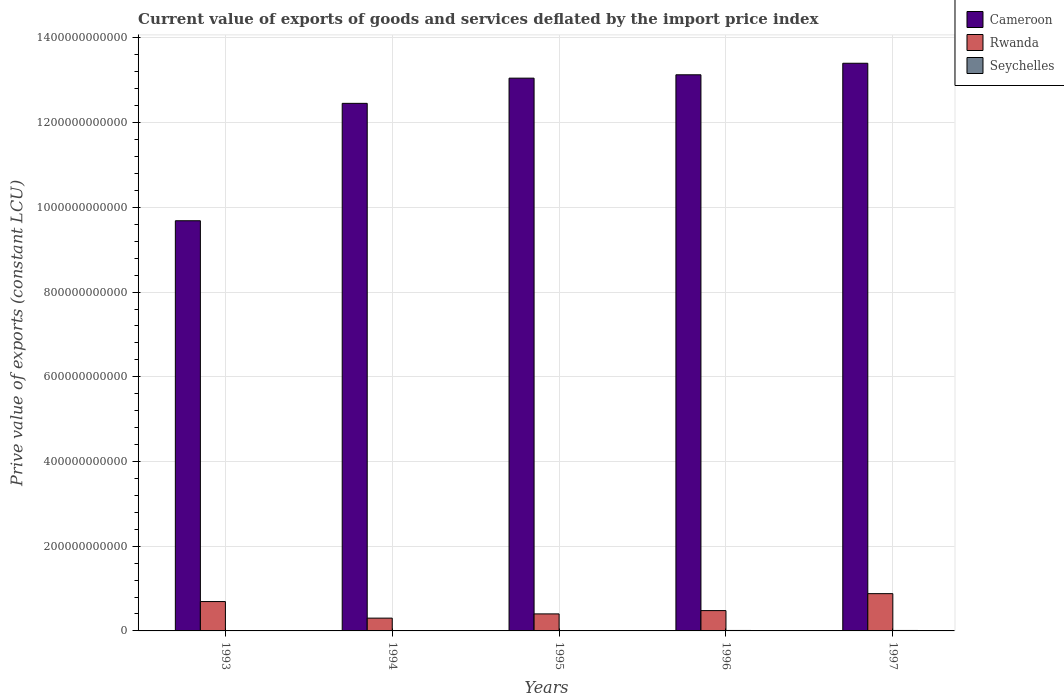How many groups of bars are there?
Offer a terse response. 5. How many bars are there on the 4th tick from the left?
Your answer should be very brief. 3. What is the label of the 5th group of bars from the left?
Ensure brevity in your answer.  1997. In how many cases, is the number of bars for a given year not equal to the number of legend labels?
Provide a short and direct response. 0. What is the prive value of exports in Cameroon in 1993?
Offer a terse response. 9.68e+11. Across all years, what is the maximum prive value of exports in Seychelles?
Give a very brief answer. 1.09e+09. Across all years, what is the minimum prive value of exports in Cameroon?
Your answer should be very brief. 9.68e+11. In which year was the prive value of exports in Rwanda maximum?
Keep it short and to the point. 1997. What is the total prive value of exports in Rwanda in the graph?
Ensure brevity in your answer.  2.76e+11. What is the difference between the prive value of exports in Cameroon in 1996 and that in 1997?
Your response must be concise. -2.72e+1. What is the difference between the prive value of exports in Seychelles in 1994 and the prive value of exports in Cameroon in 1995?
Your response must be concise. -1.30e+12. What is the average prive value of exports in Seychelles per year?
Your response must be concise. 7.48e+08. In the year 1997, what is the difference between the prive value of exports in Cameroon and prive value of exports in Seychelles?
Offer a terse response. 1.34e+12. In how many years, is the prive value of exports in Rwanda greater than 440000000000 LCU?
Keep it short and to the point. 0. What is the ratio of the prive value of exports in Seychelles in 1993 to that in 1996?
Keep it short and to the point. 0.49. Is the prive value of exports in Cameroon in 1994 less than that in 1995?
Your answer should be very brief. Yes. Is the difference between the prive value of exports in Cameroon in 1993 and 1995 greater than the difference between the prive value of exports in Seychelles in 1993 and 1995?
Your answer should be compact. No. What is the difference between the highest and the second highest prive value of exports in Seychelles?
Provide a succinct answer. 1.69e+07. What is the difference between the highest and the lowest prive value of exports in Seychelles?
Offer a very short reply. 5.79e+08. In how many years, is the prive value of exports in Seychelles greater than the average prive value of exports in Seychelles taken over all years?
Make the answer very short. 2. Is the sum of the prive value of exports in Rwanda in 1995 and 1996 greater than the maximum prive value of exports in Cameroon across all years?
Provide a succinct answer. No. What does the 3rd bar from the left in 1997 represents?
Your response must be concise. Seychelles. What does the 1st bar from the right in 1993 represents?
Provide a succinct answer. Seychelles. Is it the case that in every year, the sum of the prive value of exports in Rwanda and prive value of exports in Cameroon is greater than the prive value of exports in Seychelles?
Offer a very short reply. Yes. How many bars are there?
Ensure brevity in your answer.  15. What is the difference between two consecutive major ticks on the Y-axis?
Keep it short and to the point. 2.00e+11. Does the graph contain any zero values?
Offer a terse response. No. Does the graph contain grids?
Give a very brief answer. Yes. Where does the legend appear in the graph?
Your response must be concise. Top right. How many legend labels are there?
Provide a short and direct response. 3. How are the legend labels stacked?
Your answer should be compact. Vertical. What is the title of the graph?
Ensure brevity in your answer.  Current value of exports of goods and services deflated by the import price index. Does "Uganda" appear as one of the legend labels in the graph?
Provide a succinct answer. No. What is the label or title of the X-axis?
Your response must be concise. Years. What is the label or title of the Y-axis?
Offer a very short reply. Prive value of exports (constant LCU). What is the Prive value of exports (constant LCU) in Cameroon in 1993?
Keep it short and to the point. 9.68e+11. What is the Prive value of exports (constant LCU) in Rwanda in 1993?
Provide a short and direct response. 6.93e+1. What is the Prive value of exports (constant LCU) of Seychelles in 1993?
Your response must be concise. 5.20e+08. What is the Prive value of exports (constant LCU) of Cameroon in 1994?
Make the answer very short. 1.25e+12. What is the Prive value of exports (constant LCU) in Rwanda in 1994?
Your answer should be compact. 3.02e+1. What is the Prive value of exports (constant LCU) in Seychelles in 1994?
Provide a succinct answer. 5.10e+08. What is the Prive value of exports (constant LCU) in Cameroon in 1995?
Offer a very short reply. 1.31e+12. What is the Prive value of exports (constant LCU) in Rwanda in 1995?
Provide a short and direct response. 4.02e+1. What is the Prive value of exports (constant LCU) of Seychelles in 1995?
Give a very brief answer. 5.49e+08. What is the Prive value of exports (constant LCU) of Cameroon in 1996?
Ensure brevity in your answer.  1.31e+12. What is the Prive value of exports (constant LCU) of Rwanda in 1996?
Give a very brief answer. 4.80e+1. What is the Prive value of exports (constant LCU) in Seychelles in 1996?
Provide a succinct answer. 1.07e+09. What is the Prive value of exports (constant LCU) in Cameroon in 1997?
Your answer should be compact. 1.34e+12. What is the Prive value of exports (constant LCU) of Rwanda in 1997?
Keep it short and to the point. 8.80e+1. What is the Prive value of exports (constant LCU) of Seychelles in 1997?
Make the answer very short. 1.09e+09. Across all years, what is the maximum Prive value of exports (constant LCU) of Cameroon?
Offer a terse response. 1.34e+12. Across all years, what is the maximum Prive value of exports (constant LCU) of Rwanda?
Provide a short and direct response. 8.80e+1. Across all years, what is the maximum Prive value of exports (constant LCU) of Seychelles?
Keep it short and to the point. 1.09e+09. Across all years, what is the minimum Prive value of exports (constant LCU) of Cameroon?
Your response must be concise. 9.68e+11. Across all years, what is the minimum Prive value of exports (constant LCU) in Rwanda?
Offer a terse response. 3.02e+1. Across all years, what is the minimum Prive value of exports (constant LCU) in Seychelles?
Ensure brevity in your answer.  5.10e+08. What is the total Prive value of exports (constant LCU) of Cameroon in the graph?
Your response must be concise. 6.17e+12. What is the total Prive value of exports (constant LCU) of Rwanda in the graph?
Make the answer very short. 2.76e+11. What is the total Prive value of exports (constant LCU) in Seychelles in the graph?
Give a very brief answer. 3.74e+09. What is the difference between the Prive value of exports (constant LCU) in Cameroon in 1993 and that in 1994?
Give a very brief answer. -2.77e+11. What is the difference between the Prive value of exports (constant LCU) of Rwanda in 1993 and that in 1994?
Offer a terse response. 3.92e+1. What is the difference between the Prive value of exports (constant LCU) of Seychelles in 1993 and that in 1994?
Offer a terse response. 1.03e+07. What is the difference between the Prive value of exports (constant LCU) in Cameroon in 1993 and that in 1995?
Provide a short and direct response. -3.37e+11. What is the difference between the Prive value of exports (constant LCU) in Rwanda in 1993 and that in 1995?
Your answer should be very brief. 2.91e+1. What is the difference between the Prive value of exports (constant LCU) of Seychelles in 1993 and that in 1995?
Ensure brevity in your answer.  -2.92e+07. What is the difference between the Prive value of exports (constant LCU) in Cameroon in 1993 and that in 1996?
Provide a succinct answer. -3.45e+11. What is the difference between the Prive value of exports (constant LCU) in Rwanda in 1993 and that in 1996?
Keep it short and to the point. 2.13e+1. What is the difference between the Prive value of exports (constant LCU) of Seychelles in 1993 and that in 1996?
Offer a terse response. -5.52e+08. What is the difference between the Prive value of exports (constant LCU) in Cameroon in 1993 and that in 1997?
Ensure brevity in your answer.  -3.72e+11. What is the difference between the Prive value of exports (constant LCU) of Rwanda in 1993 and that in 1997?
Make the answer very short. -1.87e+1. What is the difference between the Prive value of exports (constant LCU) of Seychelles in 1993 and that in 1997?
Make the answer very short. -5.69e+08. What is the difference between the Prive value of exports (constant LCU) of Cameroon in 1994 and that in 1995?
Provide a succinct answer. -5.95e+1. What is the difference between the Prive value of exports (constant LCU) in Rwanda in 1994 and that in 1995?
Offer a very short reply. -1.00e+1. What is the difference between the Prive value of exports (constant LCU) in Seychelles in 1994 and that in 1995?
Offer a terse response. -3.94e+07. What is the difference between the Prive value of exports (constant LCU) in Cameroon in 1994 and that in 1996?
Provide a short and direct response. -6.74e+1. What is the difference between the Prive value of exports (constant LCU) of Rwanda in 1994 and that in 1996?
Provide a succinct answer. -1.78e+1. What is the difference between the Prive value of exports (constant LCU) in Seychelles in 1994 and that in 1996?
Your response must be concise. -5.62e+08. What is the difference between the Prive value of exports (constant LCU) of Cameroon in 1994 and that in 1997?
Your answer should be compact. -9.46e+1. What is the difference between the Prive value of exports (constant LCU) of Rwanda in 1994 and that in 1997?
Provide a short and direct response. -5.78e+1. What is the difference between the Prive value of exports (constant LCU) of Seychelles in 1994 and that in 1997?
Give a very brief answer. -5.79e+08. What is the difference between the Prive value of exports (constant LCU) of Cameroon in 1995 and that in 1996?
Provide a short and direct response. -7.94e+09. What is the difference between the Prive value of exports (constant LCU) of Rwanda in 1995 and that in 1996?
Your answer should be very brief. -7.81e+09. What is the difference between the Prive value of exports (constant LCU) of Seychelles in 1995 and that in 1996?
Ensure brevity in your answer.  -5.23e+08. What is the difference between the Prive value of exports (constant LCU) of Cameroon in 1995 and that in 1997?
Your response must be concise. -3.52e+1. What is the difference between the Prive value of exports (constant LCU) of Rwanda in 1995 and that in 1997?
Make the answer very short. -4.78e+1. What is the difference between the Prive value of exports (constant LCU) of Seychelles in 1995 and that in 1997?
Give a very brief answer. -5.40e+08. What is the difference between the Prive value of exports (constant LCU) in Cameroon in 1996 and that in 1997?
Provide a succinct answer. -2.72e+1. What is the difference between the Prive value of exports (constant LCU) in Rwanda in 1996 and that in 1997?
Provide a short and direct response. -4.00e+1. What is the difference between the Prive value of exports (constant LCU) of Seychelles in 1996 and that in 1997?
Ensure brevity in your answer.  -1.69e+07. What is the difference between the Prive value of exports (constant LCU) in Cameroon in 1993 and the Prive value of exports (constant LCU) in Rwanda in 1994?
Your response must be concise. 9.38e+11. What is the difference between the Prive value of exports (constant LCU) in Cameroon in 1993 and the Prive value of exports (constant LCU) in Seychelles in 1994?
Provide a short and direct response. 9.68e+11. What is the difference between the Prive value of exports (constant LCU) of Rwanda in 1993 and the Prive value of exports (constant LCU) of Seychelles in 1994?
Offer a terse response. 6.88e+1. What is the difference between the Prive value of exports (constant LCU) in Cameroon in 1993 and the Prive value of exports (constant LCU) in Rwanda in 1995?
Ensure brevity in your answer.  9.28e+11. What is the difference between the Prive value of exports (constant LCU) of Cameroon in 1993 and the Prive value of exports (constant LCU) of Seychelles in 1995?
Keep it short and to the point. 9.68e+11. What is the difference between the Prive value of exports (constant LCU) in Rwanda in 1993 and the Prive value of exports (constant LCU) in Seychelles in 1995?
Keep it short and to the point. 6.88e+1. What is the difference between the Prive value of exports (constant LCU) in Cameroon in 1993 and the Prive value of exports (constant LCU) in Rwanda in 1996?
Your answer should be very brief. 9.20e+11. What is the difference between the Prive value of exports (constant LCU) in Cameroon in 1993 and the Prive value of exports (constant LCU) in Seychelles in 1996?
Ensure brevity in your answer.  9.67e+11. What is the difference between the Prive value of exports (constant LCU) in Rwanda in 1993 and the Prive value of exports (constant LCU) in Seychelles in 1996?
Your response must be concise. 6.83e+1. What is the difference between the Prive value of exports (constant LCU) in Cameroon in 1993 and the Prive value of exports (constant LCU) in Rwanda in 1997?
Your answer should be very brief. 8.80e+11. What is the difference between the Prive value of exports (constant LCU) of Cameroon in 1993 and the Prive value of exports (constant LCU) of Seychelles in 1997?
Your response must be concise. 9.67e+11. What is the difference between the Prive value of exports (constant LCU) of Rwanda in 1993 and the Prive value of exports (constant LCU) of Seychelles in 1997?
Your answer should be compact. 6.82e+1. What is the difference between the Prive value of exports (constant LCU) in Cameroon in 1994 and the Prive value of exports (constant LCU) in Rwanda in 1995?
Ensure brevity in your answer.  1.21e+12. What is the difference between the Prive value of exports (constant LCU) in Cameroon in 1994 and the Prive value of exports (constant LCU) in Seychelles in 1995?
Ensure brevity in your answer.  1.25e+12. What is the difference between the Prive value of exports (constant LCU) of Rwanda in 1994 and the Prive value of exports (constant LCU) of Seychelles in 1995?
Your answer should be compact. 2.96e+1. What is the difference between the Prive value of exports (constant LCU) in Cameroon in 1994 and the Prive value of exports (constant LCU) in Rwanda in 1996?
Ensure brevity in your answer.  1.20e+12. What is the difference between the Prive value of exports (constant LCU) of Cameroon in 1994 and the Prive value of exports (constant LCU) of Seychelles in 1996?
Offer a terse response. 1.24e+12. What is the difference between the Prive value of exports (constant LCU) of Rwanda in 1994 and the Prive value of exports (constant LCU) of Seychelles in 1996?
Offer a very short reply. 2.91e+1. What is the difference between the Prive value of exports (constant LCU) in Cameroon in 1994 and the Prive value of exports (constant LCU) in Rwanda in 1997?
Keep it short and to the point. 1.16e+12. What is the difference between the Prive value of exports (constant LCU) in Cameroon in 1994 and the Prive value of exports (constant LCU) in Seychelles in 1997?
Offer a very short reply. 1.24e+12. What is the difference between the Prive value of exports (constant LCU) in Rwanda in 1994 and the Prive value of exports (constant LCU) in Seychelles in 1997?
Your answer should be very brief. 2.91e+1. What is the difference between the Prive value of exports (constant LCU) of Cameroon in 1995 and the Prive value of exports (constant LCU) of Rwanda in 1996?
Your response must be concise. 1.26e+12. What is the difference between the Prive value of exports (constant LCU) in Cameroon in 1995 and the Prive value of exports (constant LCU) in Seychelles in 1996?
Your answer should be very brief. 1.30e+12. What is the difference between the Prive value of exports (constant LCU) in Rwanda in 1995 and the Prive value of exports (constant LCU) in Seychelles in 1996?
Your response must be concise. 3.91e+1. What is the difference between the Prive value of exports (constant LCU) of Cameroon in 1995 and the Prive value of exports (constant LCU) of Rwanda in 1997?
Keep it short and to the point. 1.22e+12. What is the difference between the Prive value of exports (constant LCU) of Cameroon in 1995 and the Prive value of exports (constant LCU) of Seychelles in 1997?
Make the answer very short. 1.30e+12. What is the difference between the Prive value of exports (constant LCU) of Rwanda in 1995 and the Prive value of exports (constant LCU) of Seychelles in 1997?
Offer a terse response. 3.91e+1. What is the difference between the Prive value of exports (constant LCU) of Cameroon in 1996 and the Prive value of exports (constant LCU) of Rwanda in 1997?
Offer a very short reply. 1.22e+12. What is the difference between the Prive value of exports (constant LCU) in Cameroon in 1996 and the Prive value of exports (constant LCU) in Seychelles in 1997?
Keep it short and to the point. 1.31e+12. What is the difference between the Prive value of exports (constant LCU) in Rwanda in 1996 and the Prive value of exports (constant LCU) in Seychelles in 1997?
Your answer should be compact. 4.69e+1. What is the average Prive value of exports (constant LCU) of Cameroon per year?
Provide a short and direct response. 1.23e+12. What is the average Prive value of exports (constant LCU) of Rwanda per year?
Your answer should be compact. 5.51e+1. What is the average Prive value of exports (constant LCU) in Seychelles per year?
Provide a succinct answer. 7.48e+08. In the year 1993, what is the difference between the Prive value of exports (constant LCU) of Cameroon and Prive value of exports (constant LCU) of Rwanda?
Provide a short and direct response. 8.99e+11. In the year 1993, what is the difference between the Prive value of exports (constant LCU) in Cameroon and Prive value of exports (constant LCU) in Seychelles?
Keep it short and to the point. 9.68e+11. In the year 1993, what is the difference between the Prive value of exports (constant LCU) in Rwanda and Prive value of exports (constant LCU) in Seychelles?
Ensure brevity in your answer.  6.88e+1. In the year 1994, what is the difference between the Prive value of exports (constant LCU) in Cameroon and Prive value of exports (constant LCU) in Rwanda?
Your answer should be compact. 1.22e+12. In the year 1994, what is the difference between the Prive value of exports (constant LCU) of Cameroon and Prive value of exports (constant LCU) of Seychelles?
Your answer should be compact. 1.25e+12. In the year 1994, what is the difference between the Prive value of exports (constant LCU) in Rwanda and Prive value of exports (constant LCU) in Seychelles?
Keep it short and to the point. 2.97e+1. In the year 1995, what is the difference between the Prive value of exports (constant LCU) of Cameroon and Prive value of exports (constant LCU) of Rwanda?
Give a very brief answer. 1.26e+12. In the year 1995, what is the difference between the Prive value of exports (constant LCU) in Cameroon and Prive value of exports (constant LCU) in Seychelles?
Make the answer very short. 1.30e+12. In the year 1995, what is the difference between the Prive value of exports (constant LCU) of Rwanda and Prive value of exports (constant LCU) of Seychelles?
Provide a succinct answer. 3.96e+1. In the year 1996, what is the difference between the Prive value of exports (constant LCU) in Cameroon and Prive value of exports (constant LCU) in Rwanda?
Your response must be concise. 1.26e+12. In the year 1996, what is the difference between the Prive value of exports (constant LCU) in Cameroon and Prive value of exports (constant LCU) in Seychelles?
Offer a very short reply. 1.31e+12. In the year 1996, what is the difference between the Prive value of exports (constant LCU) of Rwanda and Prive value of exports (constant LCU) of Seychelles?
Your answer should be compact. 4.69e+1. In the year 1997, what is the difference between the Prive value of exports (constant LCU) of Cameroon and Prive value of exports (constant LCU) of Rwanda?
Make the answer very short. 1.25e+12. In the year 1997, what is the difference between the Prive value of exports (constant LCU) in Cameroon and Prive value of exports (constant LCU) in Seychelles?
Offer a terse response. 1.34e+12. In the year 1997, what is the difference between the Prive value of exports (constant LCU) of Rwanda and Prive value of exports (constant LCU) of Seychelles?
Your answer should be very brief. 8.69e+1. What is the ratio of the Prive value of exports (constant LCU) in Cameroon in 1993 to that in 1994?
Your answer should be compact. 0.78. What is the ratio of the Prive value of exports (constant LCU) of Rwanda in 1993 to that in 1994?
Your answer should be very brief. 2.3. What is the ratio of the Prive value of exports (constant LCU) in Seychelles in 1993 to that in 1994?
Make the answer very short. 1.02. What is the ratio of the Prive value of exports (constant LCU) of Cameroon in 1993 to that in 1995?
Your answer should be compact. 0.74. What is the ratio of the Prive value of exports (constant LCU) of Rwanda in 1993 to that in 1995?
Keep it short and to the point. 1.73. What is the ratio of the Prive value of exports (constant LCU) of Seychelles in 1993 to that in 1995?
Ensure brevity in your answer.  0.95. What is the ratio of the Prive value of exports (constant LCU) in Cameroon in 1993 to that in 1996?
Provide a short and direct response. 0.74. What is the ratio of the Prive value of exports (constant LCU) in Rwanda in 1993 to that in 1996?
Keep it short and to the point. 1.44. What is the ratio of the Prive value of exports (constant LCU) in Seychelles in 1993 to that in 1996?
Keep it short and to the point. 0.49. What is the ratio of the Prive value of exports (constant LCU) of Cameroon in 1993 to that in 1997?
Make the answer very short. 0.72. What is the ratio of the Prive value of exports (constant LCU) in Rwanda in 1993 to that in 1997?
Provide a short and direct response. 0.79. What is the ratio of the Prive value of exports (constant LCU) of Seychelles in 1993 to that in 1997?
Offer a terse response. 0.48. What is the ratio of the Prive value of exports (constant LCU) of Cameroon in 1994 to that in 1995?
Make the answer very short. 0.95. What is the ratio of the Prive value of exports (constant LCU) in Rwanda in 1994 to that in 1995?
Make the answer very short. 0.75. What is the ratio of the Prive value of exports (constant LCU) in Seychelles in 1994 to that in 1995?
Offer a very short reply. 0.93. What is the ratio of the Prive value of exports (constant LCU) of Cameroon in 1994 to that in 1996?
Offer a terse response. 0.95. What is the ratio of the Prive value of exports (constant LCU) in Rwanda in 1994 to that in 1996?
Give a very brief answer. 0.63. What is the ratio of the Prive value of exports (constant LCU) of Seychelles in 1994 to that in 1996?
Offer a very short reply. 0.48. What is the ratio of the Prive value of exports (constant LCU) in Cameroon in 1994 to that in 1997?
Your answer should be very brief. 0.93. What is the ratio of the Prive value of exports (constant LCU) in Rwanda in 1994 to that in 1997?
Ensure brevity in your answer.  0.34. What is the ratio of the Prive value of exports (constant LCU) in Seychelles in 1994 to that in 1997?
Offer a very short reply. 0.47. What is the ratio of the Prive value of exports (constant LCU) of Rwanda in 1995 to that in 1996?
Offer a terse response. 0.84. What is the ratio of the Prive value of exports (constant LCU) of Seychelles in 1995 to that in 1996?
Make the answer very short. 0.51. What is the ratio of the Prive value of exports (constant LCU) in Cameroon in 1995 to that in 1997?
Provide a short and direct response. 0.97. What is the ratio of the Prive value of exports (constant LCU) in Rwanda in 1995 to that in 1997?
Offer a very short reply. 0.46. What is the ratio of the Prive value of exports (constant LCU) of Seychelles in 1995 to that in 1997?
Offer a terse response. 0.5. What is the ratio of the Prive value of exports (constant LCU) of Cameroon in 1996 to that in 1997?
Ensure brevity in your answer.  0.98. What is the ratio of the Prive value of exports (constant LCU) of Rwanda in 1996 to that in 1997?
Offer a terse response. 0.55. What is the ratio of the Prive value of exports (constant LCU) of Seychelles in 1996 to that in 1997?
Provide a short and direct response. 0.98. What is the difference between the highest and the second highest Prive value of exports (constant LCU) of Cameroon?
Ensure brevity in your answer.  2.72e+1. What is the difference between the highest and the second highest Prive value of exports (constant LCU) in Rwanda?
Make the answer very short. 1.87e+1. What is the difference between the highest and the second highest Prive value of exports (constant LCU) in Seychelles?
Give a very brief answer. 1.69e+07. What is the difference between the highest and the lowest Prive value of exports (constant LCU) of Cameroon?
Your answer should be compact. 3.72e+11. What is the difference between the highest and the lowest Prive value of exports (constant LCU) of Rwanda?
Your answer should be very brief. 5.78e+1. What is the difference between the highest and the lowest Prive value of exports (constant LCU) in Seychelles?
Make the answer very short. 5.79e+08. 